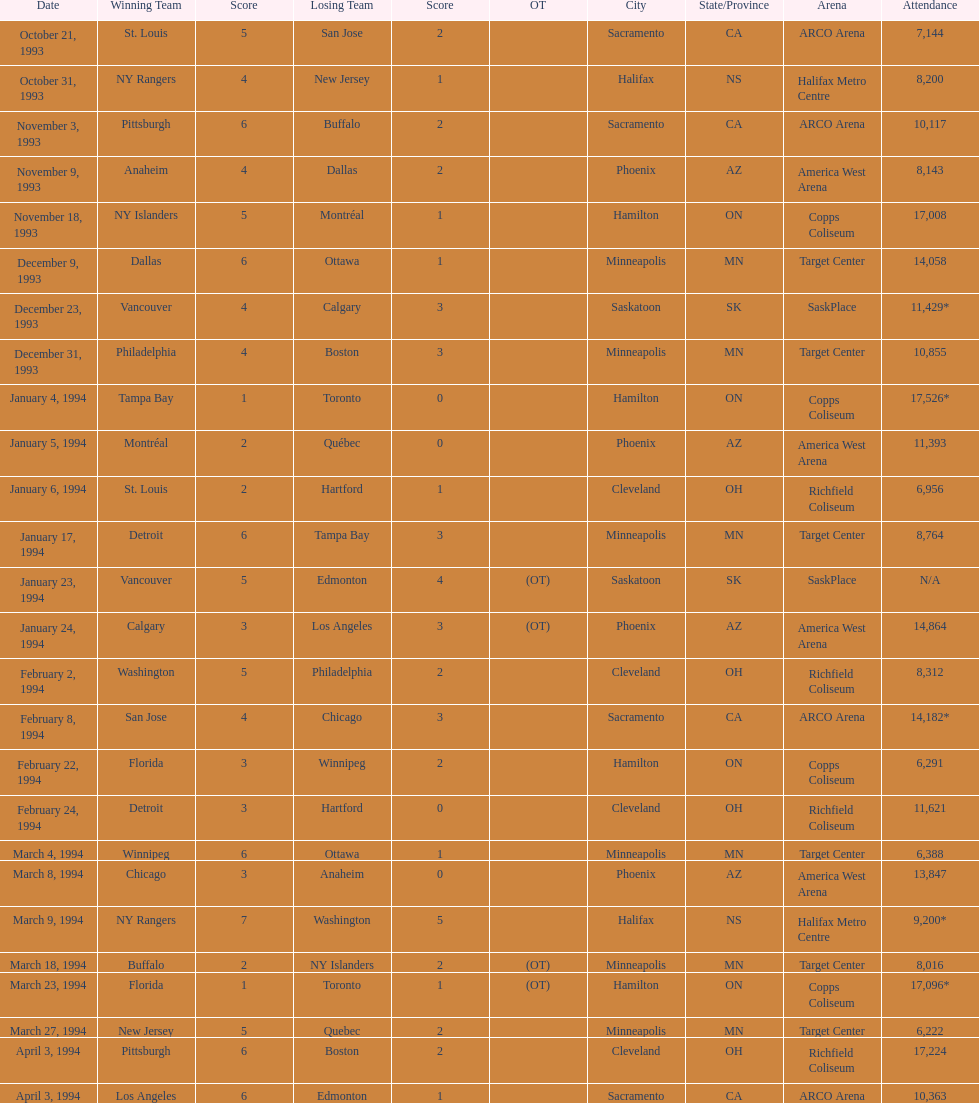What dates witnessed the winning side scoring a single point? January 4, 1994, March 23, 1994. Out of these two, which date had a larger audience? January 4, 1994. 